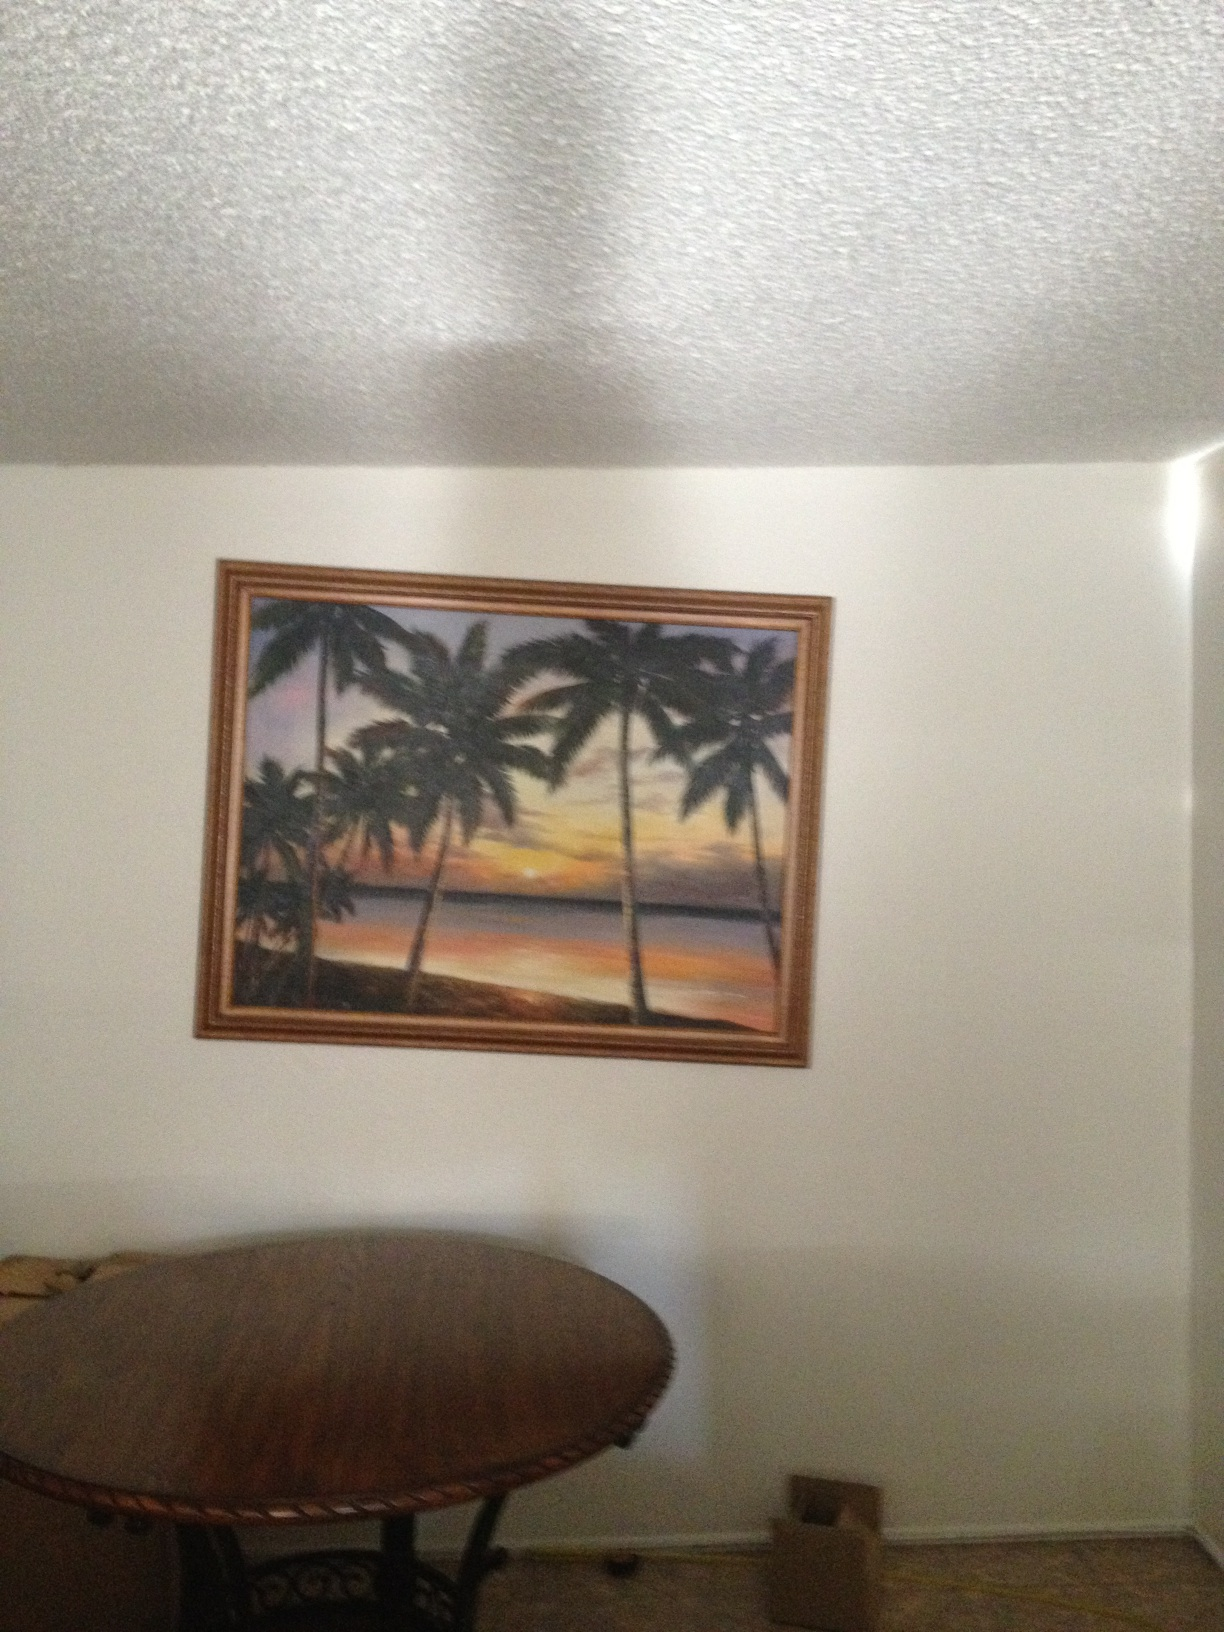Is this painting right-side up, or upside down? That's all I need to know. Thank you. The painting is indeed right-side up. You can identify its correct orientation by the way the palm trees grow upward and how the sunset illuminates the scene from below the horizon, creating a natural view of a tropical dusk. 